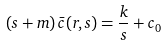<formula> <loc_0><loc_0><loc_500><loc_500>( s + m ) \, \bar { c } ( r , s ) = \frac { k } { s } + c _ { 0 }</formula> 